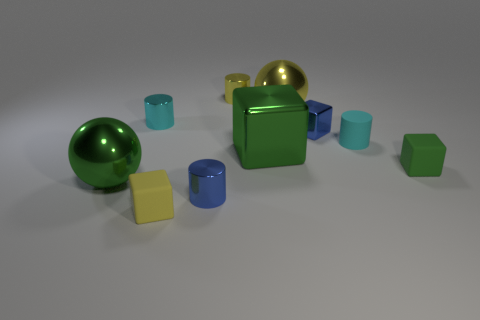Is there any pattern to the arrangement of the objects? The arrangement of objects seems somewhat random, but there's a loose left-to-right ascending size order, with smaller objects on the left side of the image gradually transitioning to larger objects on the right. 